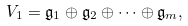Convert formula to latex. <formula><loc_0><loc_0><loc_500><loc_500>V _ { 1 } = \mathfrak { g } _ { 1 } \oplus \mathfrak { g } _ { 2 } \oplus \cdots \oplus \mathfrak { g } _ { m } ,</formula> 